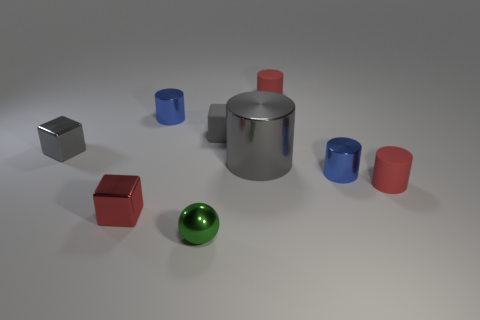Subtract all gray cylinders. How many cylinders are left? 4 Subtract all gray cylinders. How many cylinders are left? 4 Subtract all brown cylinders. Subtract all blue spheres. How many cylinders are left? 5 Add 1 blue matte cylinders. How many objects exist? 10 Subtract all cylinders. How many objects are left? 4 Add 4 tiny red rubber cubes. How many tiny red rubber cubes exist? 4 Subtract 0 yellow spheres. How many objects are left? 9 Subtract all metal cylinders. Subtract all small blue shiny cubes. How many objects are left? 6 Add 3 gray things. How many gray things are left? 6 